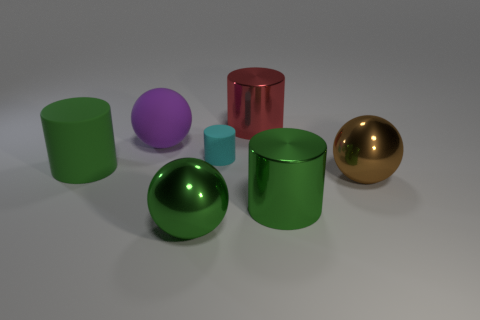Add 1 big brown shiny things. How many objects exist? 8 Subtract all balls. How many objects are left? 4 Subtract all brown matte blocks. Subtract all cyan matte cylinders. How many objects are left? 6 Add 5 tiny cylinders. How many tiny cylinders are left? 6 Add 2 small purple spheres. How many small purple spheres exist? 2 Subtract 0 cyan blocks. How many objects are left? 7 